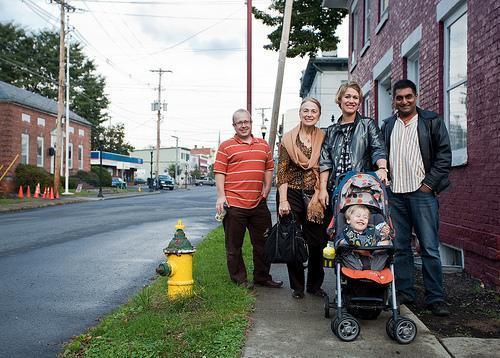How many people on the sidewalk?
Give a very brief answer. 5. How many children in the group of people?
Give a very brief answer. 1. 